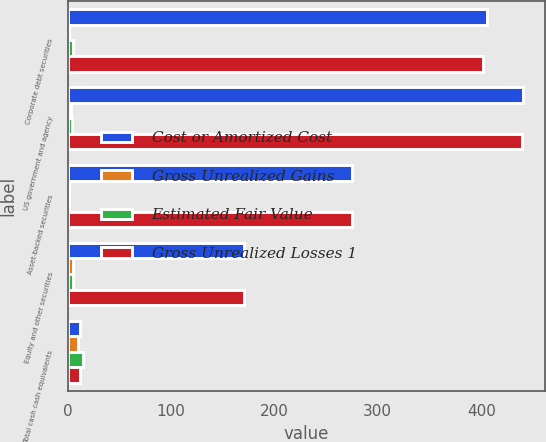Convert chart. <chart><loc_0><loc_0><loc_500><loc_500><stacked_bar_chart><ecel><fcel>Corporate debt securities<fcel>US government and agency<fcel>Asset-backed securities<fcel>Equity and other securities<fcel>Total cash cash equivalents<nl><fcel>Cost or Amortized Cost<fcel>406<fcel>440<fcel>275<fcel>171<fcel>12.5<nl><fcel>Gross Unrealized Gains<fcel>1<fcel>3<fcel>1<fcel>5<fcel>10<nl><fcel>Estimated Fair Value<fcel>5<fcel>4<fcel>1<fcel>5<fcel>15<nl><fcel>Gross Unrealized Losses 1<fcel>402<fcel>439<fcel>275<fcel>171<fcel>12.5<nl></chart> 